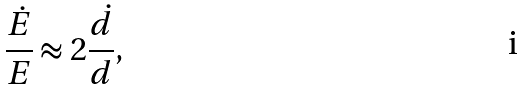<formula> <loc_0><loc_0><loc_500><loc_500>\frac { \dot { E } } { E } \approx 2 \frac { \dot { d } } { d } ,</formula> 